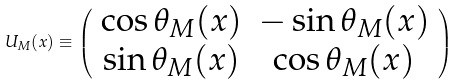Convert formula to latex. <formula><loc_0><loc_0><loc_500><loc_500>U _ { M } ( x ) \equiv \left ( \begin{array} { c c } \cos \theta _ { M } ( x ) & - \sin \theta _ { M } ( x ) \\ \sin \theta _ { M } ( x ) & \cos \theta _ { M } ( x ) \end{array} \right )</formula> 